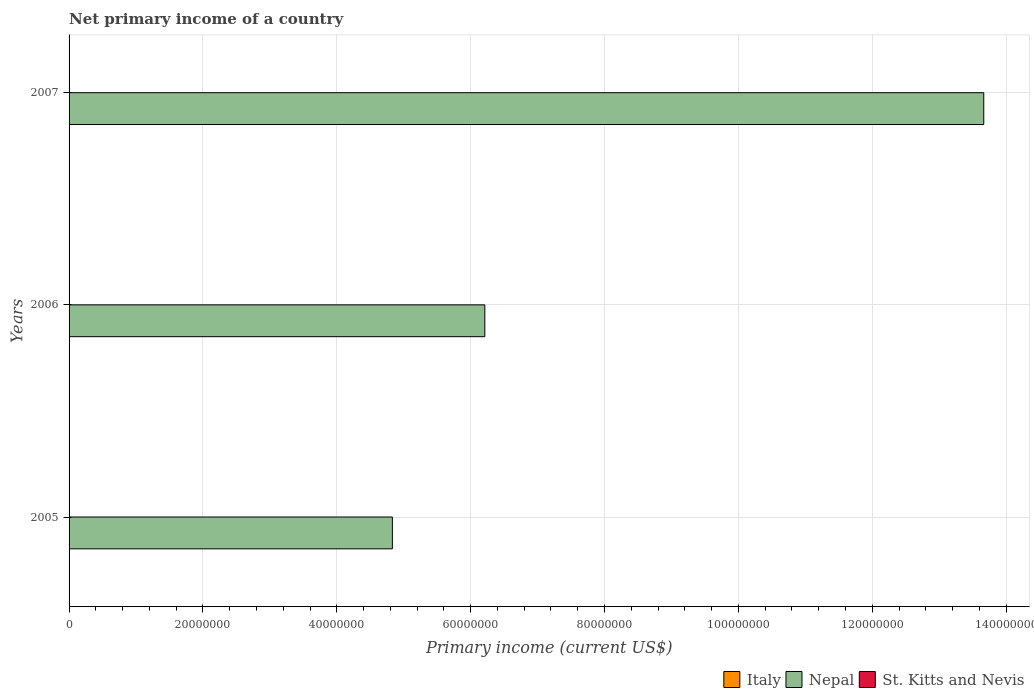How many different coloured bars are there?
Your answer should be compact. 1. Are the number of bars on each tick of the Y-axis equal?
Give a very brief answer. Yes. How many bars are there on the 3rd tick from the top?
Keep it short and to the point. 1. How many bars are there on the 2nd tick from the bottom?
Offer a very short reply. 1. What is the primary income in St. Kitts and Nevis in 2006?
Keep it short and to the point. 0. Across all years, what is the maximum primary income in Nepal?
Give a very brief answer. 1.37e+08. Across all years, what is the minimum primary income in St. Kitts and Nevis?
Provide a succinct answer. 0. In which year was the primary income in Nepal maximum?
Your answer should be very brief. 2007. What is the total primary income in St. Kitts and Nevis in the graph?
Offer a terse response. 0. What is the difference between the primary income in Nepal in 2005 and that in 2006?
Provide a short and direct response. -1.38e+07. What is the difference between the primary income in Nepal in 2006 and the primary income in St. Kitts and Nevis in 2005?
Provide a succinct answer. 6.21e+07. What is the average primary income in Nepal per year?
Give a very brief answer. 8.24e+07. In how many years, is the primary income in Italy greater than 136000000 US$?
Offer a very short reply. 0. What is the ratio of the primary income in Nepal in 2005 to that in 2006?
Make the answer very short. 0.78. Is the primary income in Nepal in 2005 less than that in 2007?
Offer a terse response. Yes. What is the difference between the highest and the second highest primary income in Nepal?
Your answer should be very brief. 7.45e+07. What is the difference between the highest and the lowest primary income in Nepal?
Ensure brevity in your answer.  8.84e+07. In how many years, is the primary income in Italy greater than the average primary income in Italy taken over all years?
Your answer should be compact. 0. Is the sum of the primary income in Nepal in 2005 and 2007 greater than the maximum primary income in Italy across all years?
Offer a terse response. Yes. Is it the case that in every year, the sum of the primary income in Nepal and primary income in Italy is greater than the primary income in St. Kitts and Nevis?
Your response must be concise. Yes. Are all the bars in the graph horizontal?
Provide a succinct answer. Yes. What is the difference between two consecutive major ticks on the X-axis?
Offer a terse response. 2.00e+07. Are the values on the major ticks of X-axis written in scientific E-notation?
Provide a succinct answer. No. Does the graph contain any zero values?
Your response must be concise. Yes. Does the graph contain grids?
Ensure brevity in your answer.  Yes. How many legend labels are there?
Make the answer very short. 3. What is the title of the graph?
Keep it short and to the point. Net primary income of a country. Does "Monaco" appear as one of the legend labels in the graph?
Ensure brevity in your answer.  No. What is the label or title of the X-axis?
Your answer should be compact. Primary income (current US$). What is the label or title of the Y-axis?
Give a very brief answer. Years. What is the Primary income (current US$) in Nepal in 2005?
Ensure brevity in your answer.  4.83e+07. What is the Primary income (current US$) of Italy in 2006?
Your answer should be compact. 0. What is the Primary income (current US$) of Nepal in 2006?
Keep it short and to the point. 6.21e+07. What is the Primary income (current US$) of St. Kitts and Nevis in 2006?
Your answer should be very brief. 0. What is the Primary income (current US$) of Nepal in 2007?
Your answer should be compact. 1.37e+08. Across all years, what is the maximum Primary income (current US$) in Nepal?
Your response must be concise. 1.37e+08. Across all years, what is the minimum Primary income (current US$) in Nepal?
Your answer should be compact. 4.83e+07. What is the total Primary income (current US$) in Italy in the graph?
Offer a terse response. 0. What is the total Primary income (current US$) of Nepal in the graph?
Offer a terse response. 2.47e+08. What is the total Primary income (current US$) in St. Kitts and Nevis in the graph?
Ensure brevity in your answer.  0. What is the difference between the Primary income (current US$) in Nepal in 2005 and that in 2006?
Your response must be concise. -1.38e+07. What is the difference between the Primary income (current US$) of Nepal in 2005 and that in 2007?
Provide a succinct answer. -8.84e+07. What is the difference between the Primary income (current US$) in Nepal in 2006 and that in 2007?
Provide a succinct answer. -7.45e+07. What is the average Primary income (current US$) in Italy per year?
Give a very brief answer. 0. What is the average Primary income (current US$) in Nepal per year?
Ensure brevity in your answer.  8.24e+07. What is the average Primary income (current US$) of St. Kitts and Nevis per year?
Ensure brevity in your answer.  0. What is the ratio of the Primary income (current US$) of Nepal in 2005 to that in 2006?
Provide a short and direct response. 0.78. What is the ratio of the Primary income (current US$) in Nepal in 2005 to that in 2007?
Give a very brief answer. 0.35. What is the ratio of the Primary income (current US$) in Nepal in 2006 to that in 2007?
Make the answer very short. 0.45. What is the difference between the highest and the second highest Primary income (current US$) in Nepal?
Provide a succinct answer. 7.45e+07. What is the difference between the highest and the lowest Primary income (current US$) in Nepal?
Provide a short and direct response. 8.84e+07. 